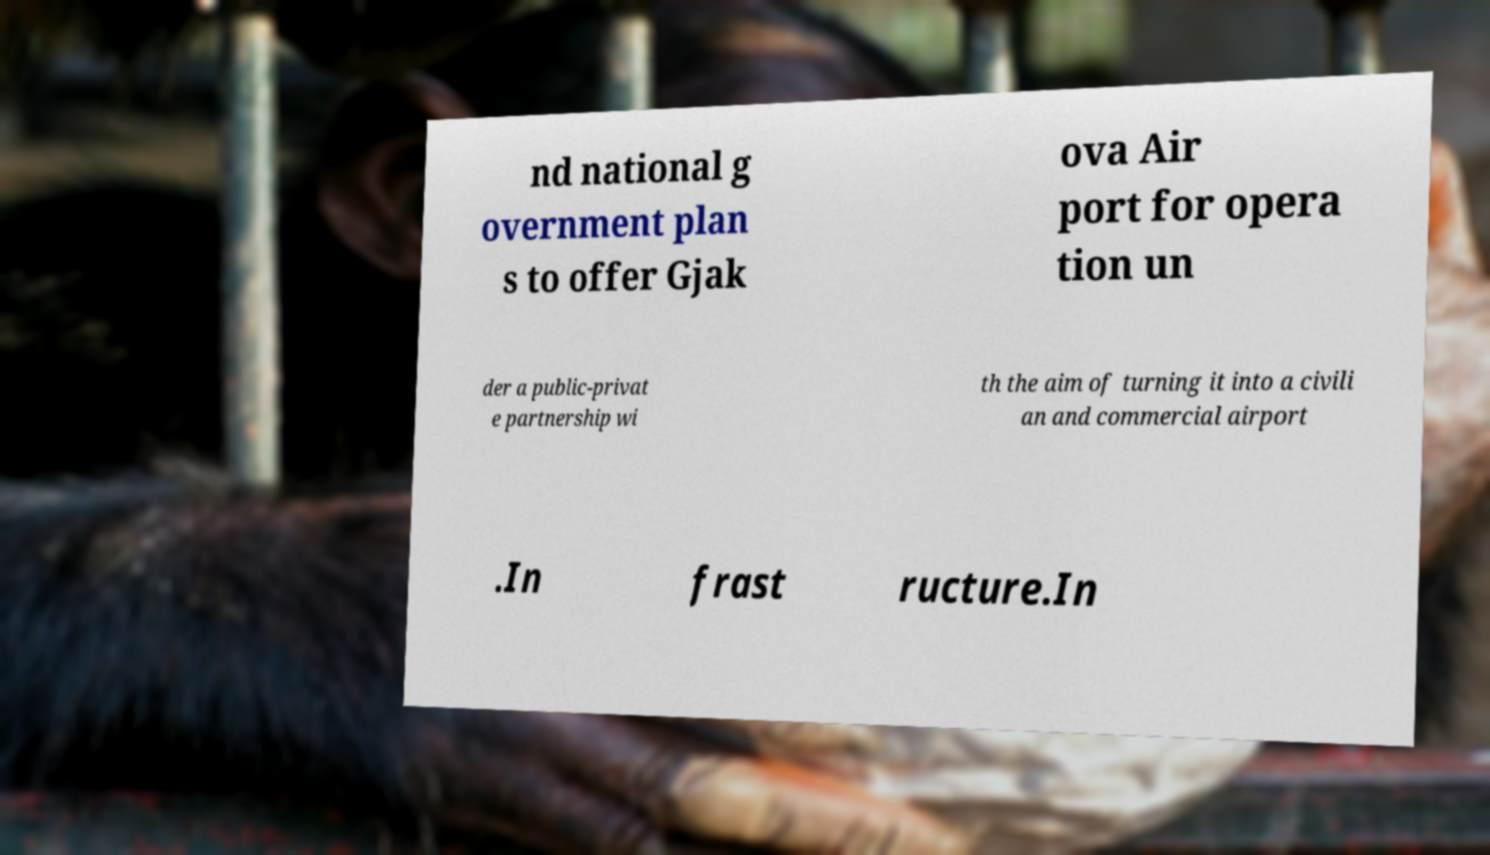Could you assist in decoding the text presented in this image and type it out clearly? nd national g overnment plan s to offer Gjak ova Air port for opera tion un der a public-privat e partnership wi th the aim of turning it into a civili an and commercial airport .In frast ructure.In 